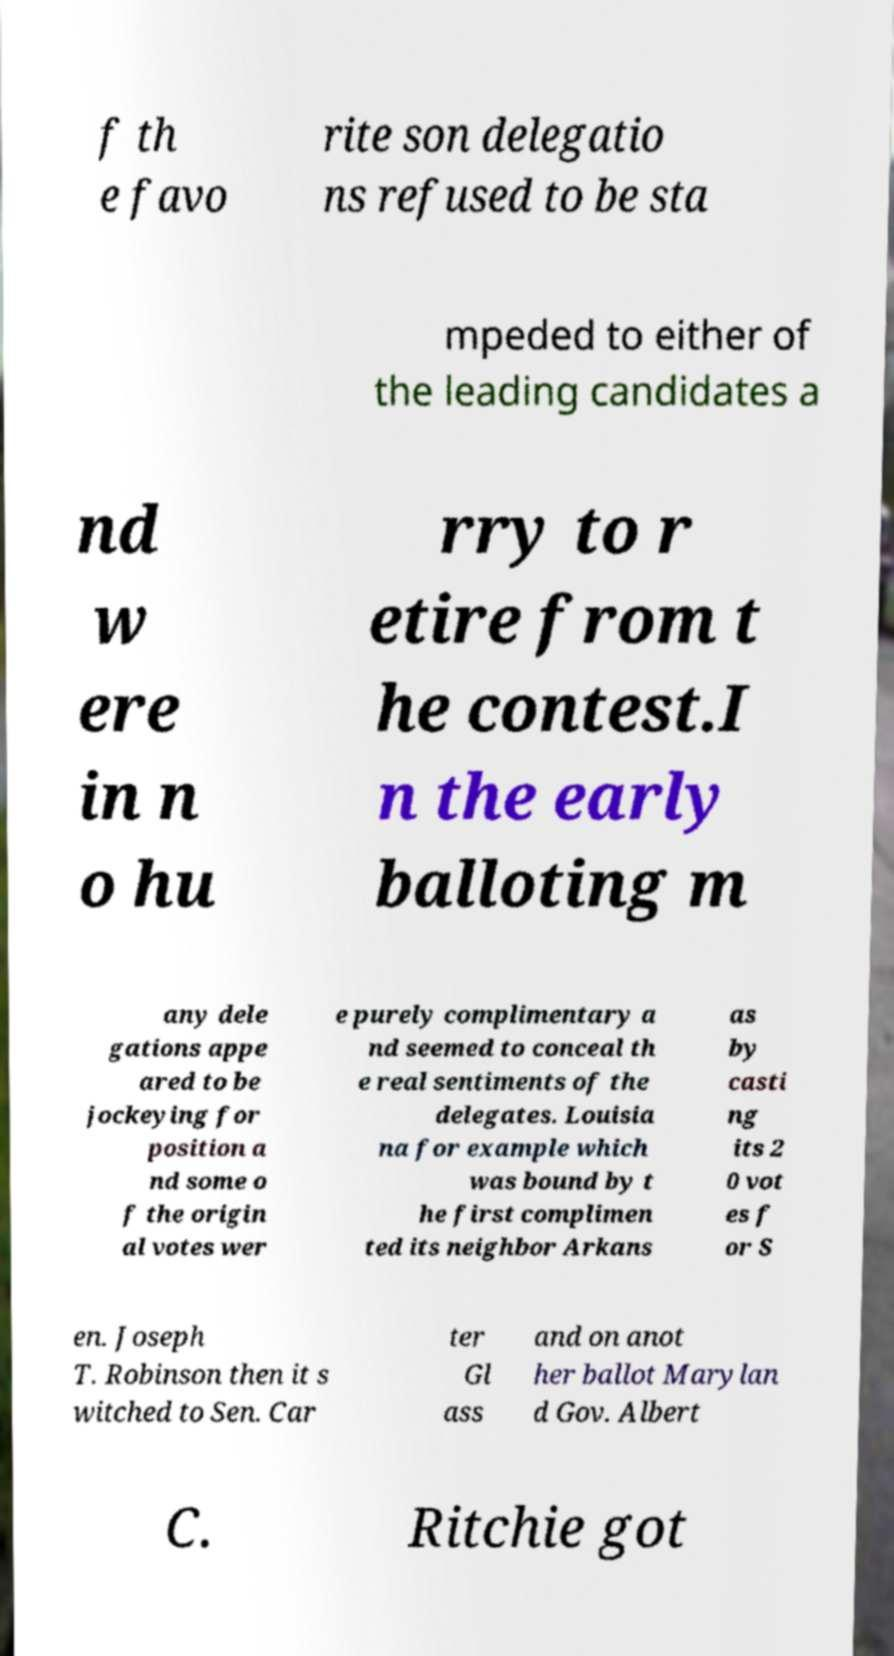There's text embedded in this image that I need extracted. Can you transcribe it verbatim? f th e favo rite son delegatio ns refused to be sta mpeded to either of the leading candidates a nd w ere in n o hu rry to r etire from t he contest.I n the early balloting m any dele gations appe ared to be jockeying for position a nd some o f the origin al votes wer e purely complimentary a nd seemed to conceal th e real sentiments of the delegates. Louisia na for example which was bound by t he first complimen ted its neighbor Arkans as by casti ng its 2 0 vot es f or S en. Joseph T. Robinson then it s witched to Sen. Car ter Gl ass and on anot her ballot Marylan d Gov. Albert C. Ritchie got 